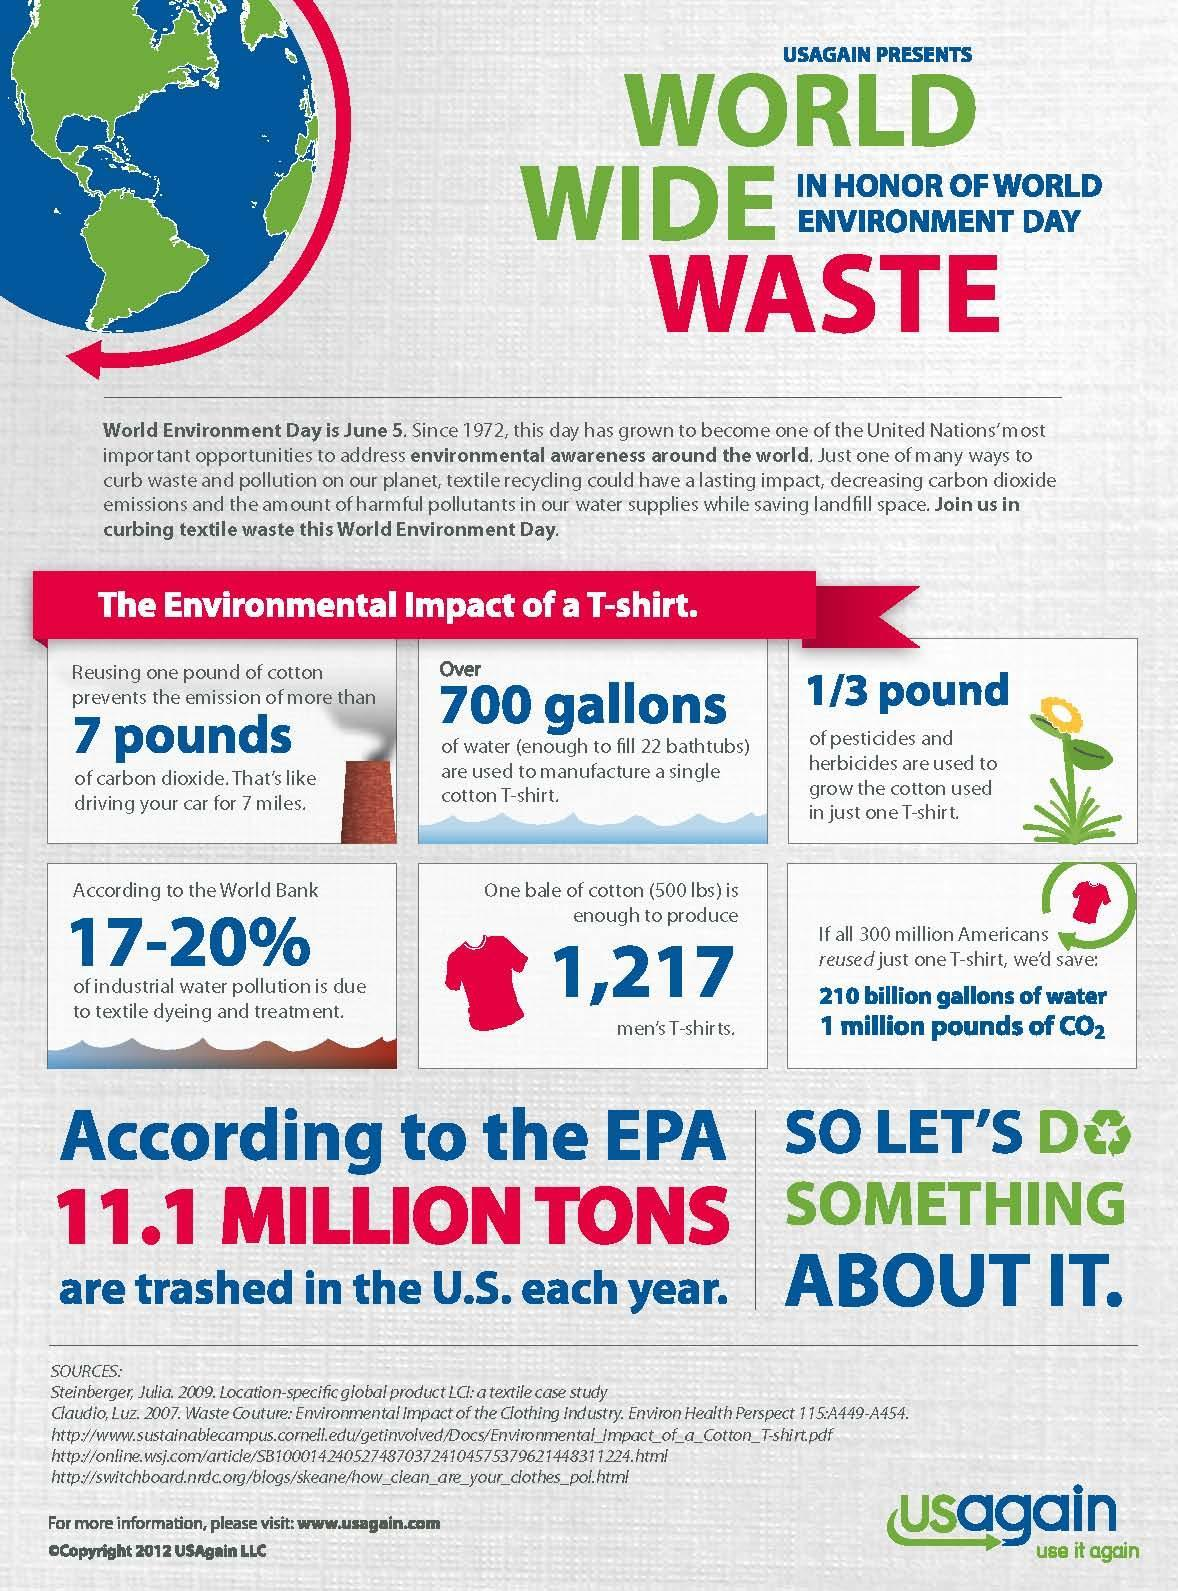How many men's T-shirts produced using one bale of cotton?
Answer the question with a short phrase. 1,217 How much water used to manufacture a single cotton T-shirt? 700 gallons What is the color of the T-shirt in this infographic-blue, red, yellow? red 